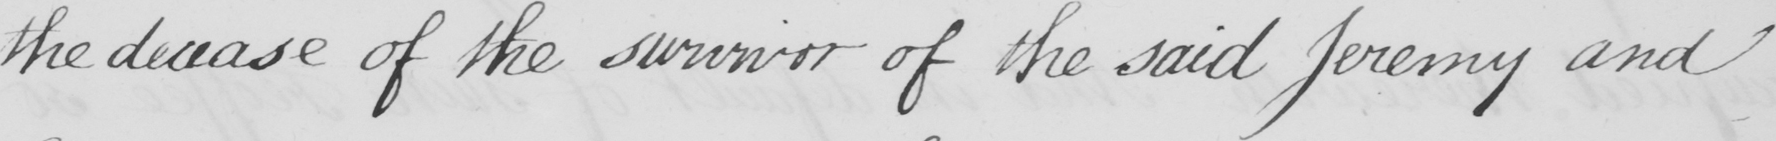What is written in this line of handwriting? the decease of the survivor of the said Jeremy and 